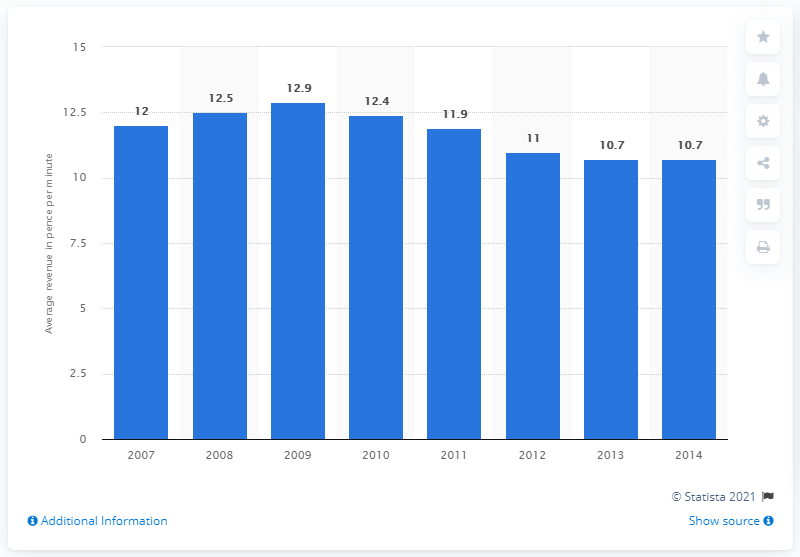Indicate a few pertinent items in this graphic. In 2013, the average revenue per fixed voice call minute of calls to mobile was 10.7 pence per minute. 